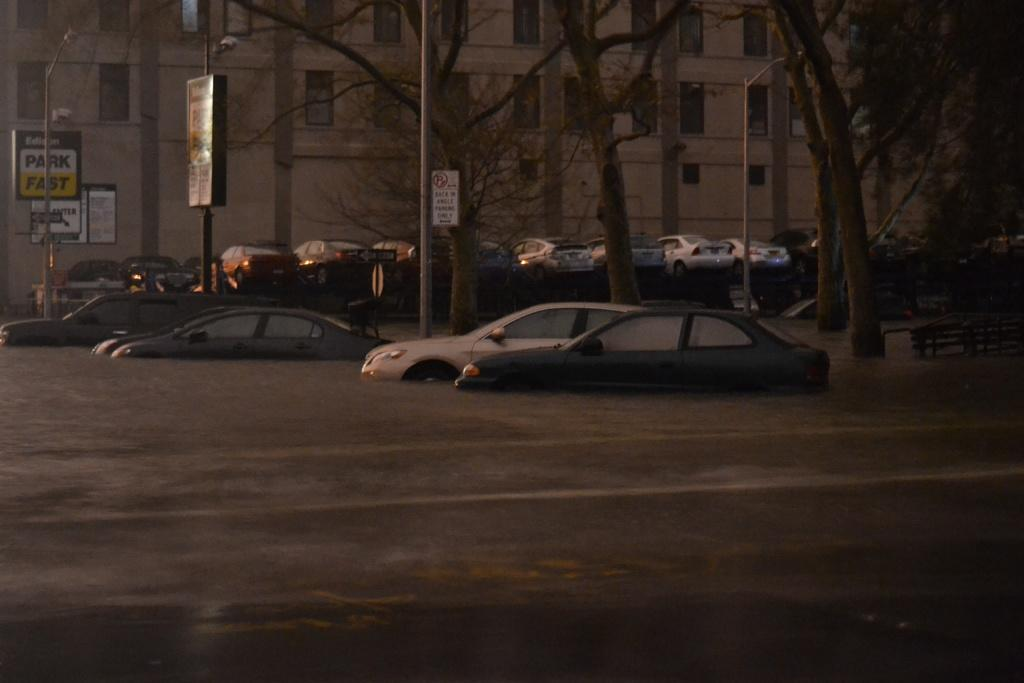What type of vehicles can be seen in the image? There are cars in the image. What structures are present in the image to provide illumination? There are light poles in the image. What type of signage is visible in the image? There are boards with text in the image. What type of structure is present in the image? There is a building in the image. What architectural feature can be seen on the building? There are windows visible in the image. Can you tell me when the baby was born in the image? There is no baby or birth information present in the image. What type of band is playing music in the image? There is no band or music playing in the image. 